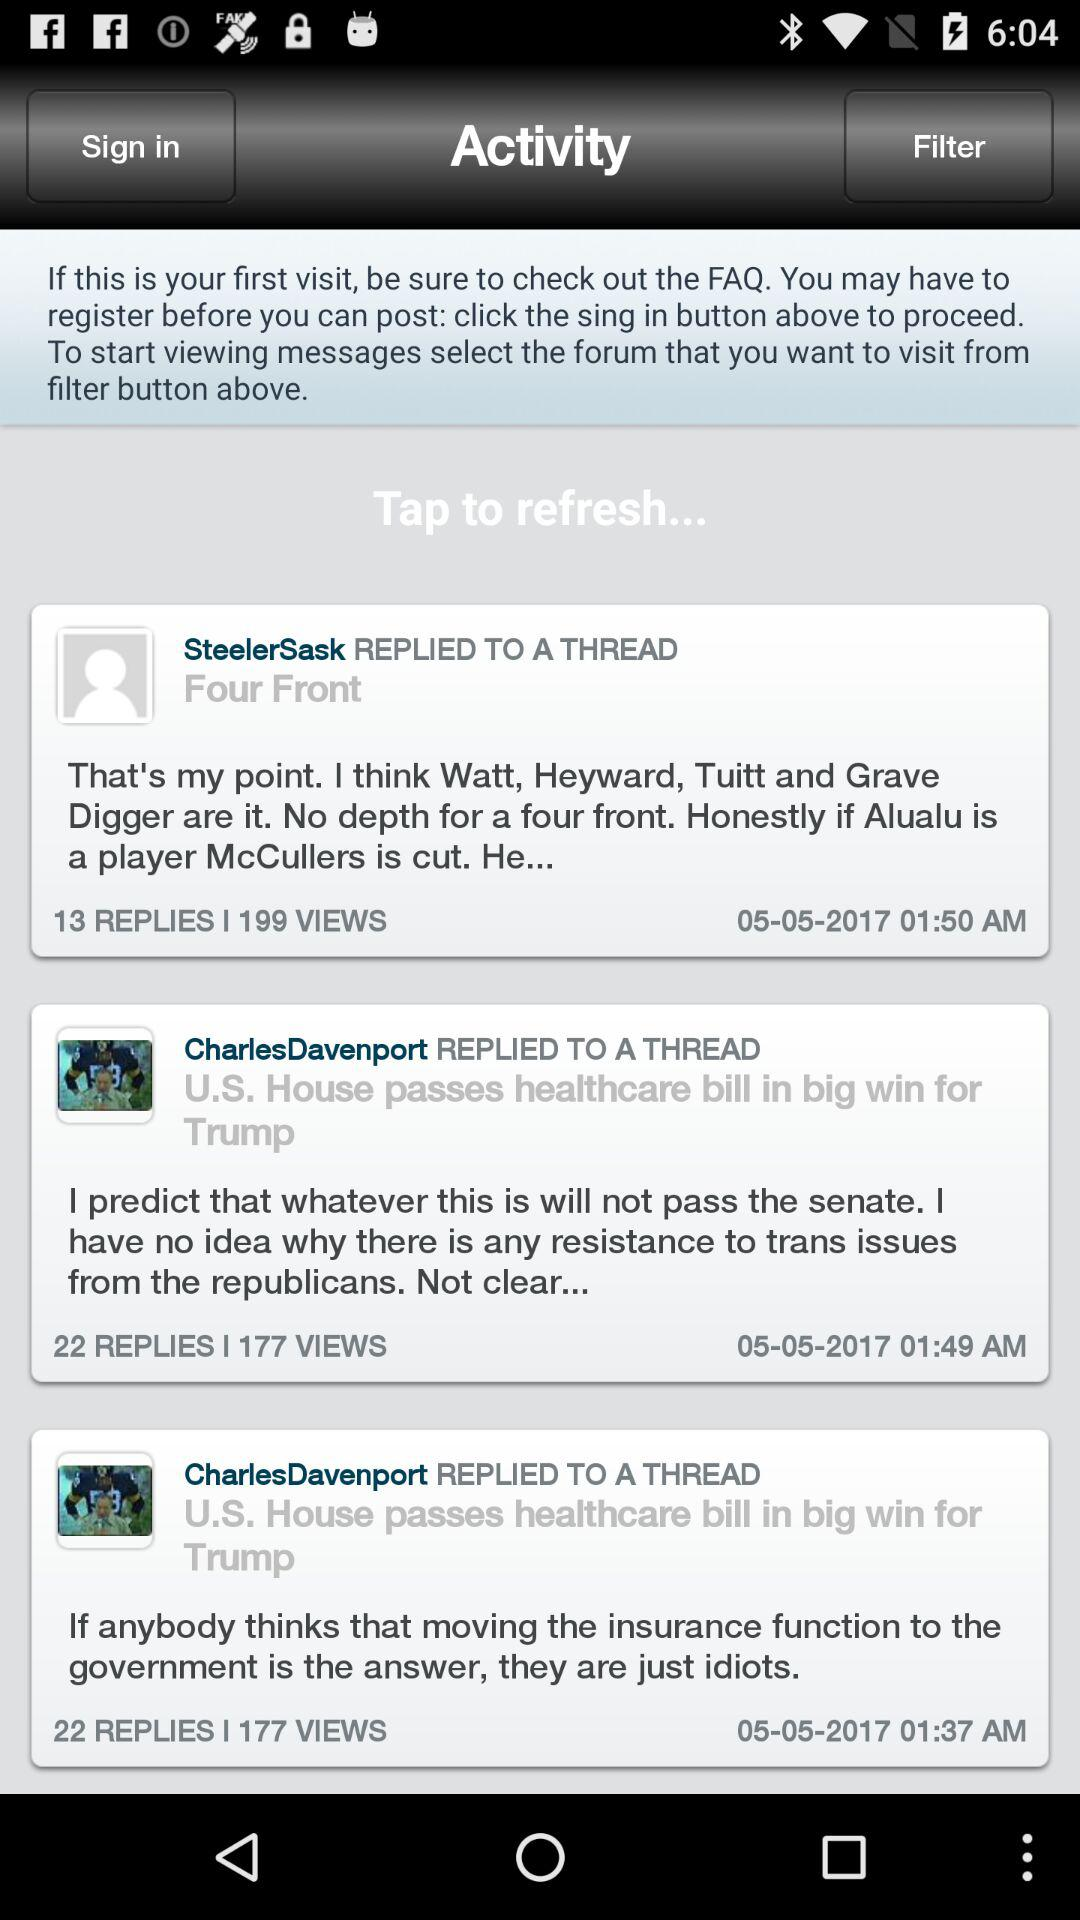At what time did SteelerSask post the comments? SteelerSask posted the comments at 1:50 AM. 